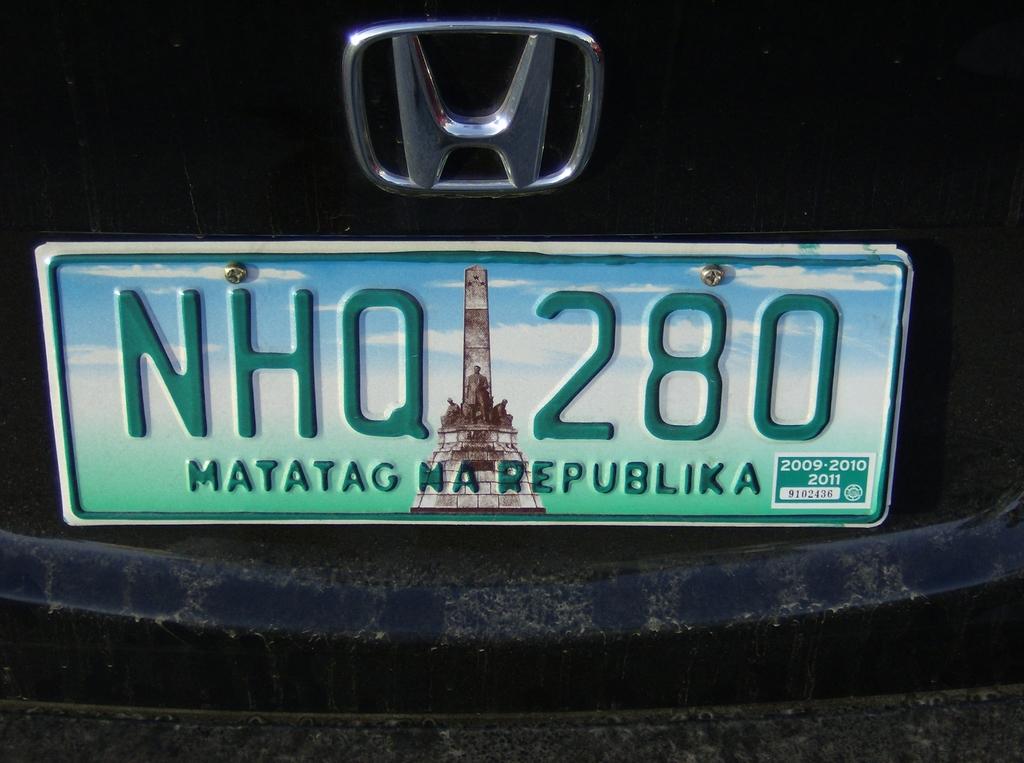What years are the registration good for?
Offer a very short reply. 2009, 2010, 2011. 